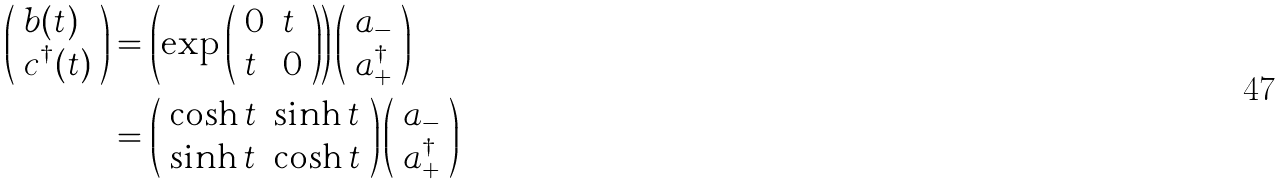Convert formula to latex. <formula><loc_0><loc_0><loc_500><loc_500>\left ( \begin{array} { l } b ( t ) \\ c ^ { \dagger } ( t ) \end{array} \right ) & = \left ( \exp \left ( \begin{array} { l l } 0 & t \\ t & 0 \end{array} \right ) \right ) \left ( \begin{array} { l } a _ { - } \\ a _ { + } ^ { \dagger } \end{array} \right ) \\ & = \left ( \begin{array} { l l } \cosh t & \sinh t \\ \sinh t & \cosh t \end{array} \right ) \left ( \begin{array} { l } a _ { - } \\ a _ { + } ^ { \dagger } \end{array} \right )</formula> 